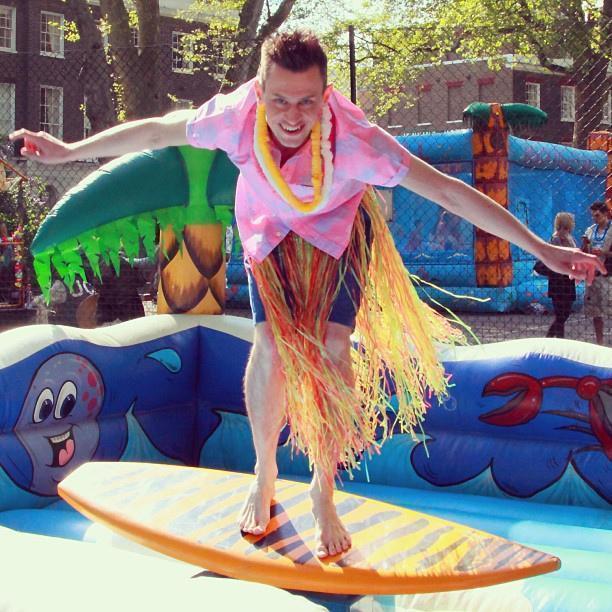What kind of animal is the cartoon face on the left?
Answer the question by selecting the correct answer among the 4 following choices and explain your choice with a short sentence. The answer should be formatted with the following format: `Answer: choice
Rationale: rationale.`
Options: Octopus, shark, bear, seal. Answer: octopus.
Rationale: The animal is an octopus. 